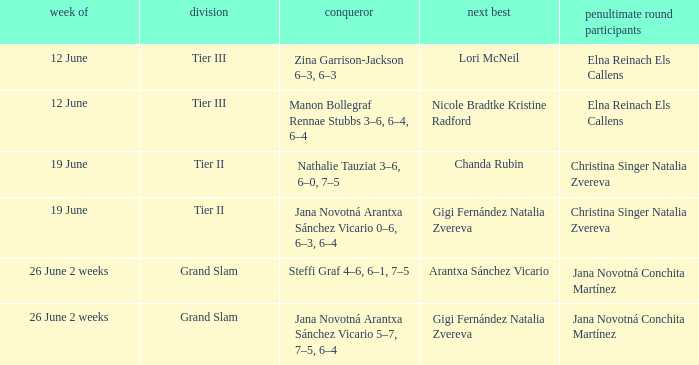In what week can we find jana novotná arantxa sánchez vicario listed as the victorious player with a 5-7, 7-5, 6-4 scoreline 26 June 2 weeks. 